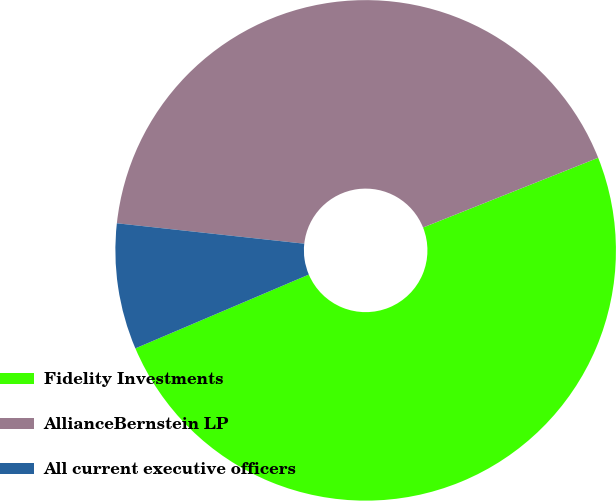<chart> <loc_0><loc_0><loc_500><loc_500><pie_chart><fcel>Fidelity Investments<fcel>AllianceBernstein LP<fcel>All current executive officers<nl><fcel>49.63%<fcel>42.24%<fcel>8.13%<nl></chart> 